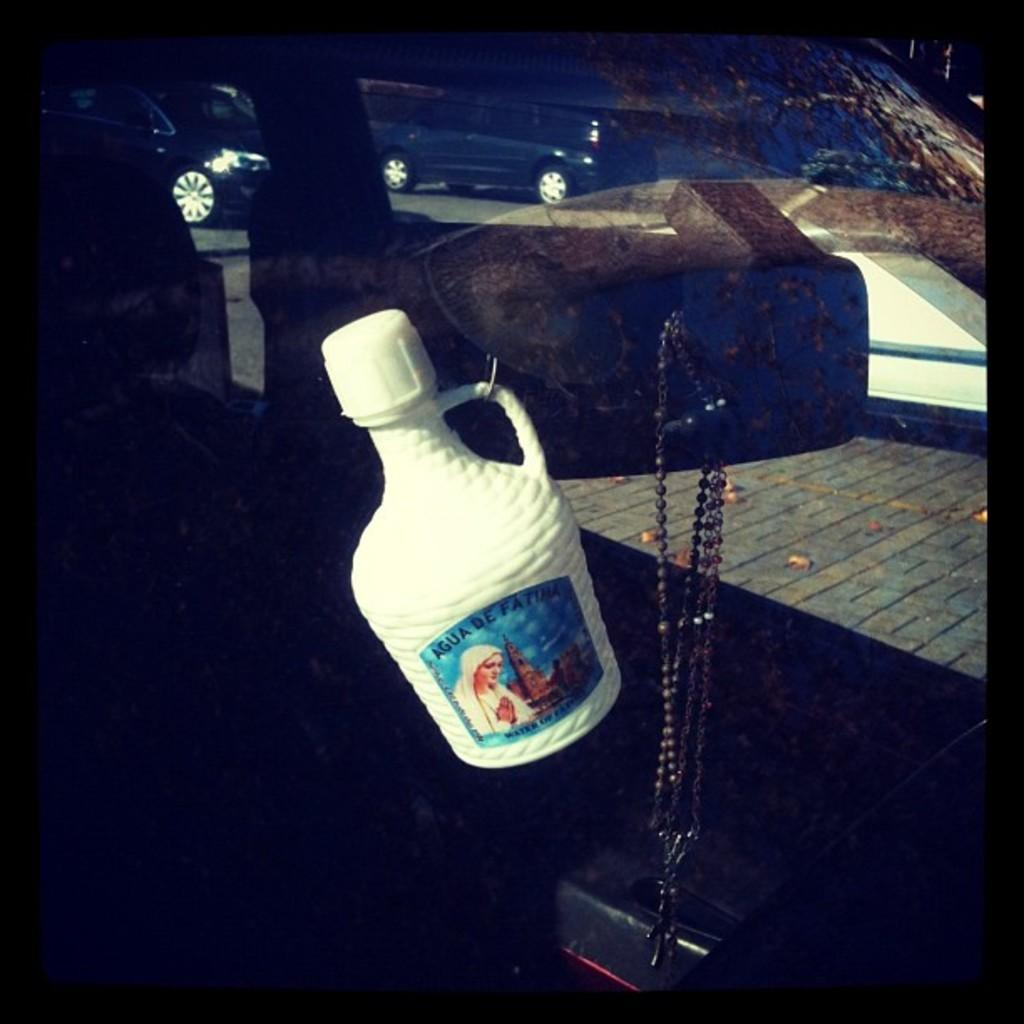What type of vehicle is in the image? There is a car in the image. What object is present that might be used for securing or connecting things? There is a chain in the image. image. What object in the image might contain a liquid? There is a bottle in the image. What type of surface is visible in the image? There is a road in the image. What type of jewel is hanging from the car's rearview mirror in the image? There is no jewel hanging from the car's rearview mirror in the image. What type of coil is wrapped around the car's tires in the image? There is no coil wrapped around the car's tires in the image. 